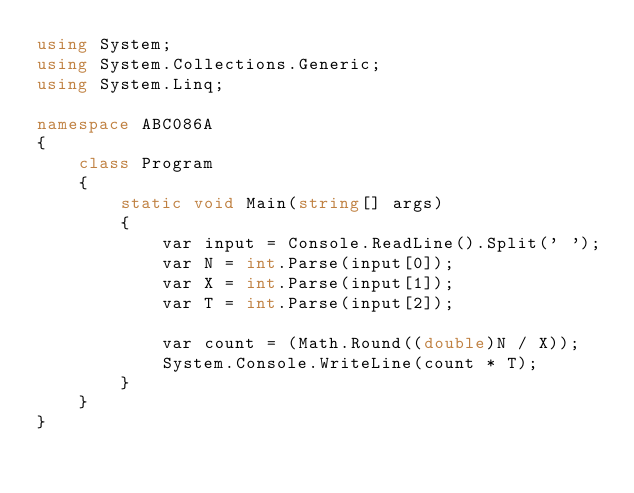<code> <loc_0><loc_0><loc_500><loc_500><_C#_>using System;
using System.Collections.Generic;
using System.Linq;

namespace ABC086A
{
    class Program
    {
        static void Main(string[] args)
        {
            var input = Console.ReadLine().Split(' ');
            var N = int.Parse(input[0]);
            var X = int.Parse(input[1]);
            var T = int.Parse(input[2]);

            var count = (Math.Round((double)N / X));
            System.Console.WriteLine(count * T);
        }
    }
}
</code> 